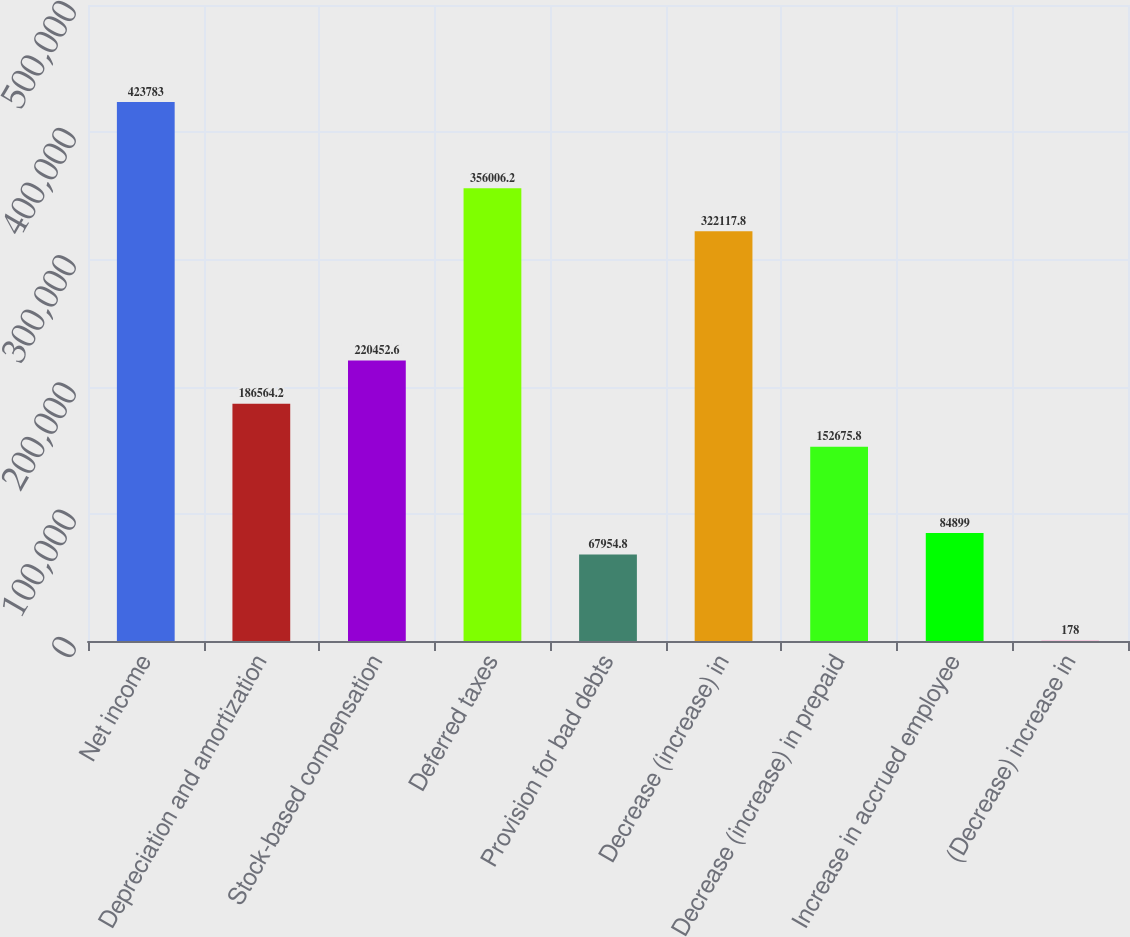Convert chart to OTSL. <chart><loc_0><loc_0><loc_500><loc_500><bar_chart><fcel>Net income<fcel>Depreciation and amortization<fcel>Stock-based compensation<fcel>Deferred taxes<fcel>Provision for bad debts<fcel>Decrease (increase) in<fcel>Decrease (increase) in prepaid<fcel>Increase in accrued employee<fcel>(Decrease) increase in<nl><fcel>423783<fcel>186564<fcel>220453<fcel>356006<fcel>67954.8<fcel>322118<fcel>152676<fcel>84899<fcel>178<nl></chart> 